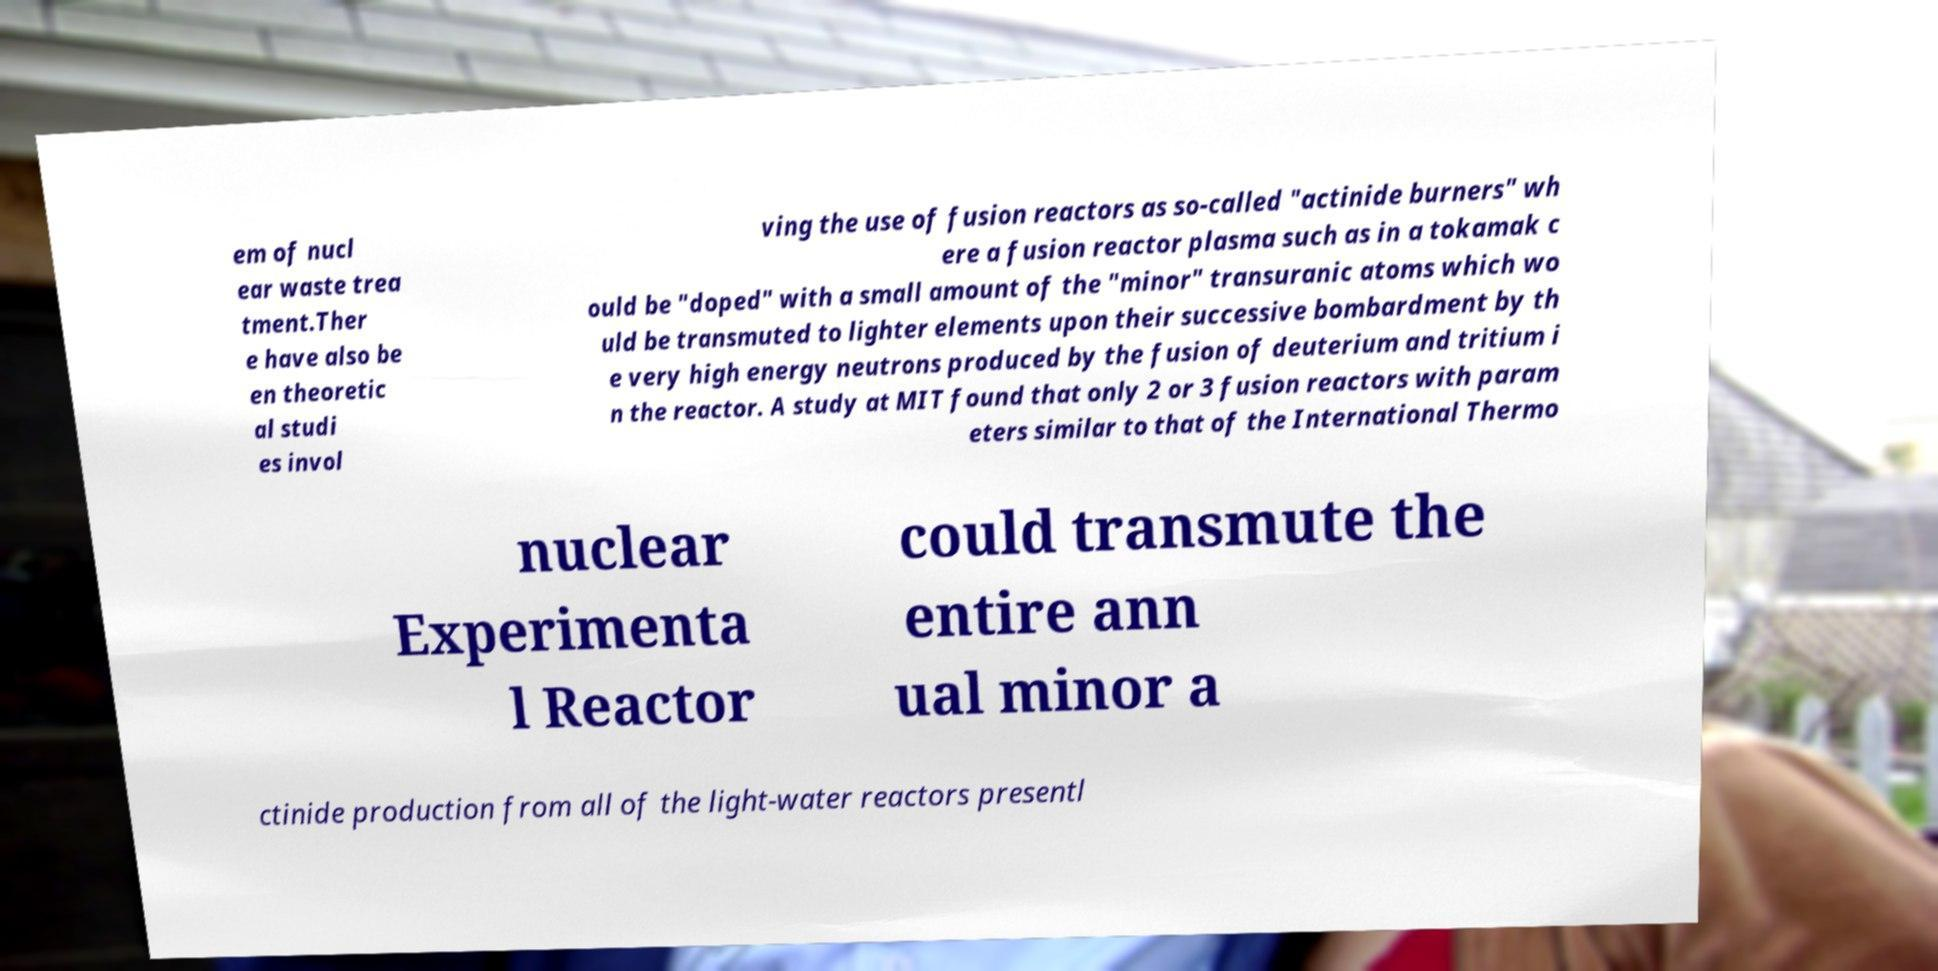Please identify and transcribe the text found in this image. em of nucl ear waste trea tment.Ther e have also be en theoretic al studi es invol ving the use of fusion reactors as so-called "actinide burners" wh ere a fusion reactor plasma such as in a tokamak c ould be "doped" with a small amount of the "minor" transuranic atoms which wo uld be transmuted to lighter elements upon their successive bombardment by th e very high energy neutrons produced by the fusion of deuterium and tritium i n the reactor. A study at MIT found that only 2 or 3 fusion reactors with param eters similar to that of the International Thermo nuclear Experimenta l Reactor could transmute the entire ann ual minor a ctinide production from all of the light-water reactors presentl 